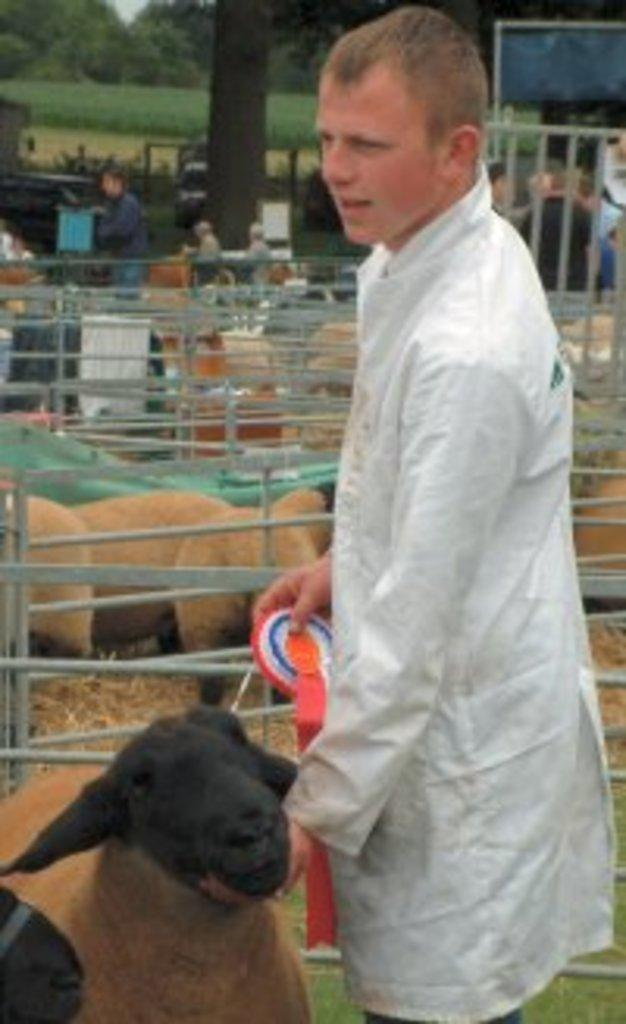Who is on the right side of the image? There is a man on the right side of the image. What animals are present in the image? There are sheep in the image. What type of material is visible in the image? There are iron rods in the image. What can be seen in the background of the image? There are persons and trees in the background of the image. How many apples are on the crate in the image? There is no crate or apple present in the image. What type of seed can be seen growing on the trees in the image? The image does not provide enough detail to determine the type of seed growing on the trees. 